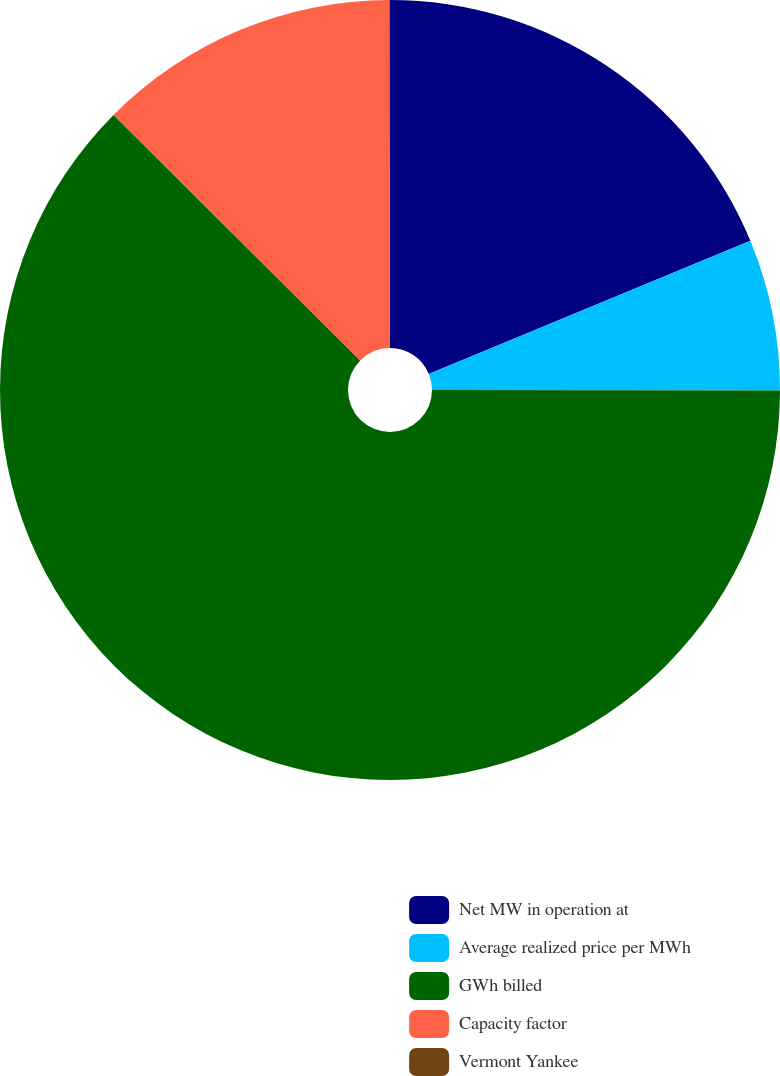<chart> <loc_0><loc_0><loc_500><loc_500><pie_chart><fcel>Net MW in operation at<fcel>Average realized price per MWh<fcel>GWh billed<fcel>Capacity factor<fcel>Vermont Yankee<nl><fcel>18.75%<fcel>6.27%<fcel>62.43%<fcel>12.51%<fcel>0.03%<nl></chart> 